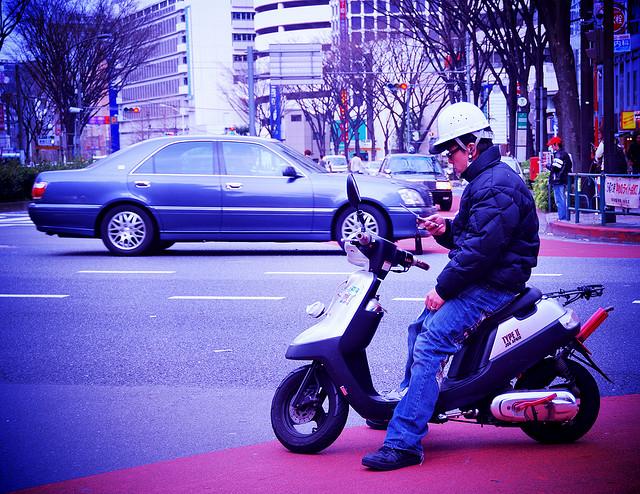What is the man looking at?
Quick response, please. Phone. Is the motorcycle in the street?
Short answer required. No. What color is the car behind the scooter?
Give a very brief answer. Blue. 